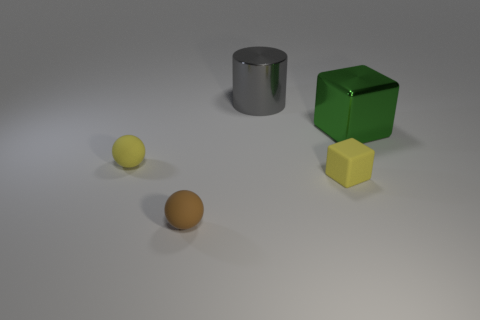Add 1 big green shiny cubes. How many objects exist? 6 Subtract all blocks. How many objects are left? 3 Subtract all gray objects. Subtract all cyan things. How many objects are left? 4 Add 4 green blocks. How many green blocks are left? 5 Add 5 large brown rubber cylinders. How many large brown rubber cylinders exist? 5 Subtract 0 green cylinders. How many objects are left? 5 